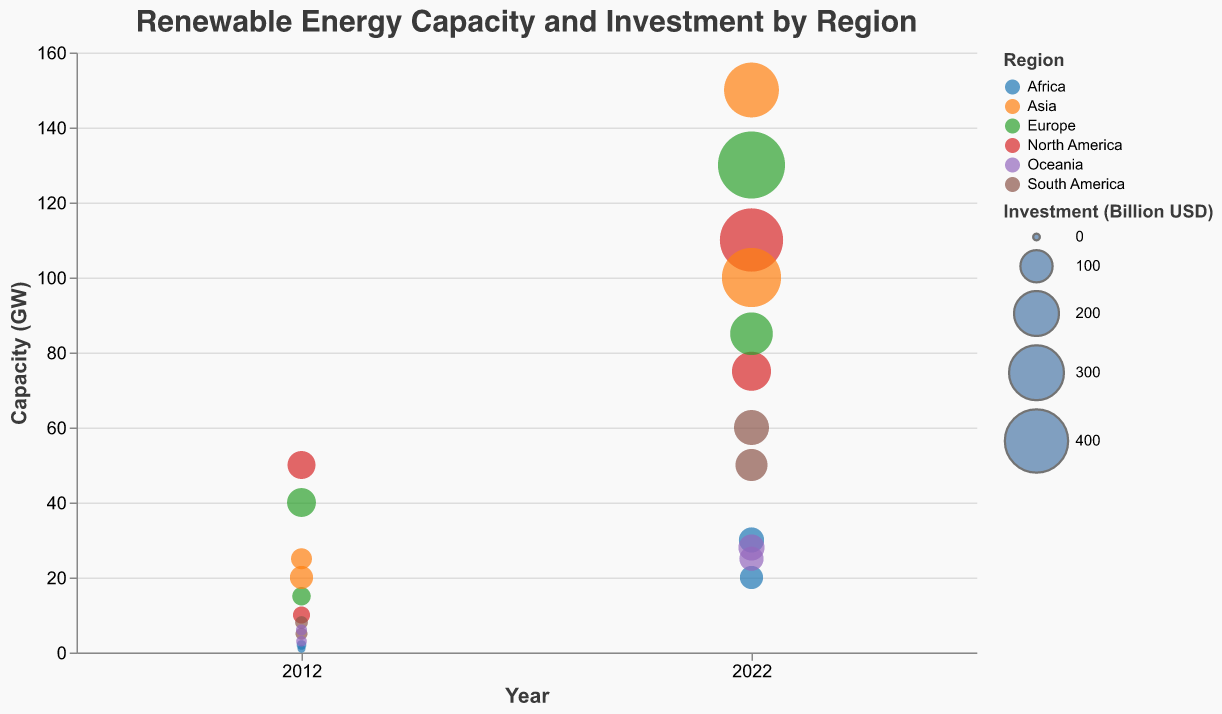How much did North America invest in solar energy in 2022? The figure shows the investment for North America in solar energy for both 2012 and 2022. In 2022, the investment for solar energy in North America is clearly labeled.
Answer: 150 billion USD Which region had the highest wind capacity in 2022? By looking at the y-axis for the capacity of wind in 2022, and comparing the values for each region, we find that Europe has the highest capacity.
Answer: Europe How much did Africa increase its solar capacity from 2012 to 2022? The figure shows Africa's solar capacity in both 2012 and 2022. The capacity increased from 2 GW in 2012 to 30 GW in 2022; so, 30 - 2 = 28 GW.
Answer: 28 GW Which region had the larger increase in wind capacity from 2012 to 2022, Asia or South America? Asia's wind capacity increased from 20 GW to 100 GW, a difference of 80 GW. South America's wind capacity increased from 8 GW to 60 GW, a difference of 52 GW. Comparing these, Asia had a larger increase.
Answer: Asia What was the total investment in solar and wind energy in South America in 2022? The total investment in South America for solar and wind in 2022 is given by adding their individual investments: 100 billion USD (solar) + 120 billion USD (wind) = 220 billion USD.
Answer: 220 billion USD How did the capacity of solar energy in Oceania change over the last decade? The y-axis shows the capacity for Oceania's solar energy in both 2012 and 2022. In 2012, it was 3 GW and in 2022, it became 25 GW. The change is 25 - 3 = 22 GW.
Answer: Increased by 22 GW What was the investment difference between wind energy in North America and Europe in 2022? The investment for wind energy in 2022 in North America is 400 billion USD, and in Europe, it is 450 billion USD. The difference is 450 - 400 = 50 billion USD.
Answer: 50 billion USD Which energy source saw the greatest increase in capacity in Asia from 2012 to 2022? Comparing capacity increases for solar and wind in Asia: Solar increased from 25 GW to 150 GW (125 GW increase), and Wind increased from 20 GW to 100 GW (80 GW increase). Therefore, solar saw the greatest increase.
Answer: Solar 